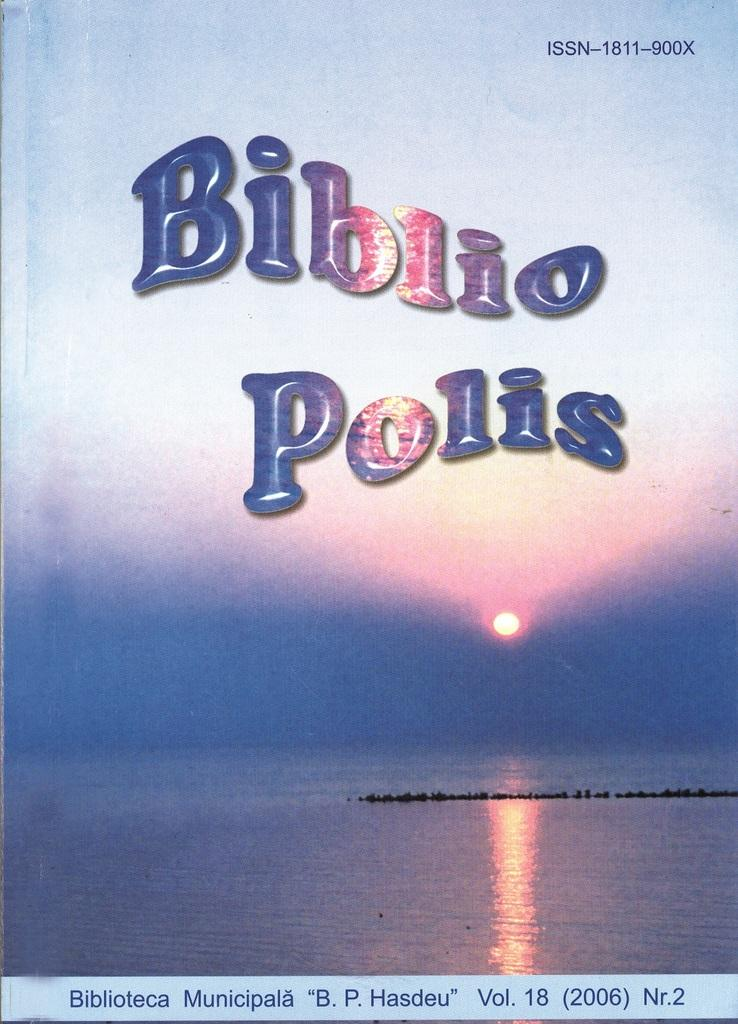<image>
Summarize the visual content of the image. Cover that says the words "Biblio Polis" in blue. 